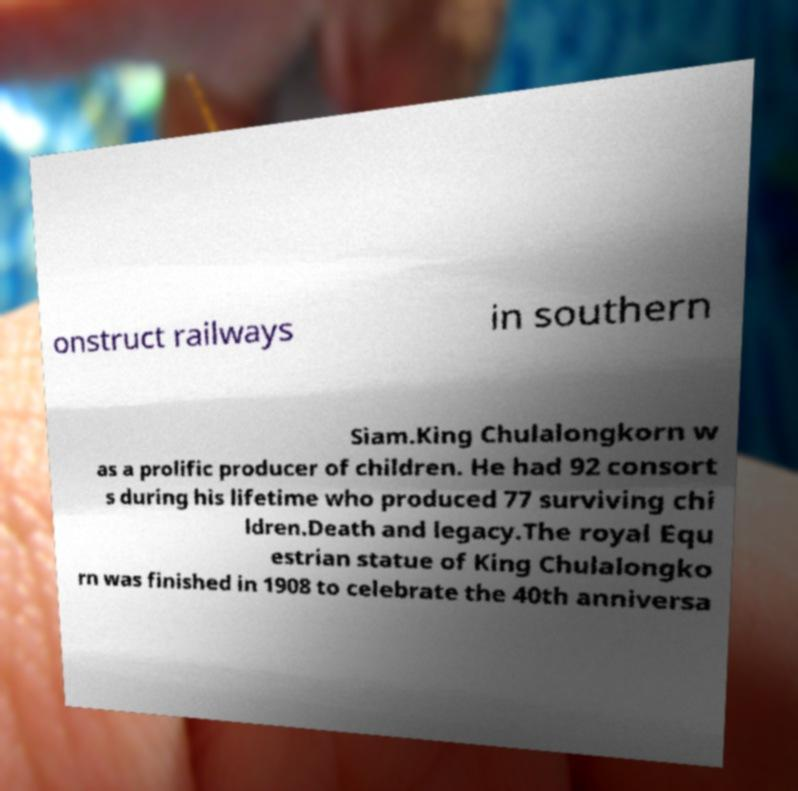There's text embedded in this image that I need extracted. Can you transcribe it verbatim? onstruct railways in southern Siam.King Chulalongkorn w as a prolific producer of children. He had 92 consort s during his lifetime who produced 77 surviving chi ldren.Death and legacy.The royal Equ estrian statue of King Chulalongko rn was finished in 1908 to celebrate the 40th anniversa 